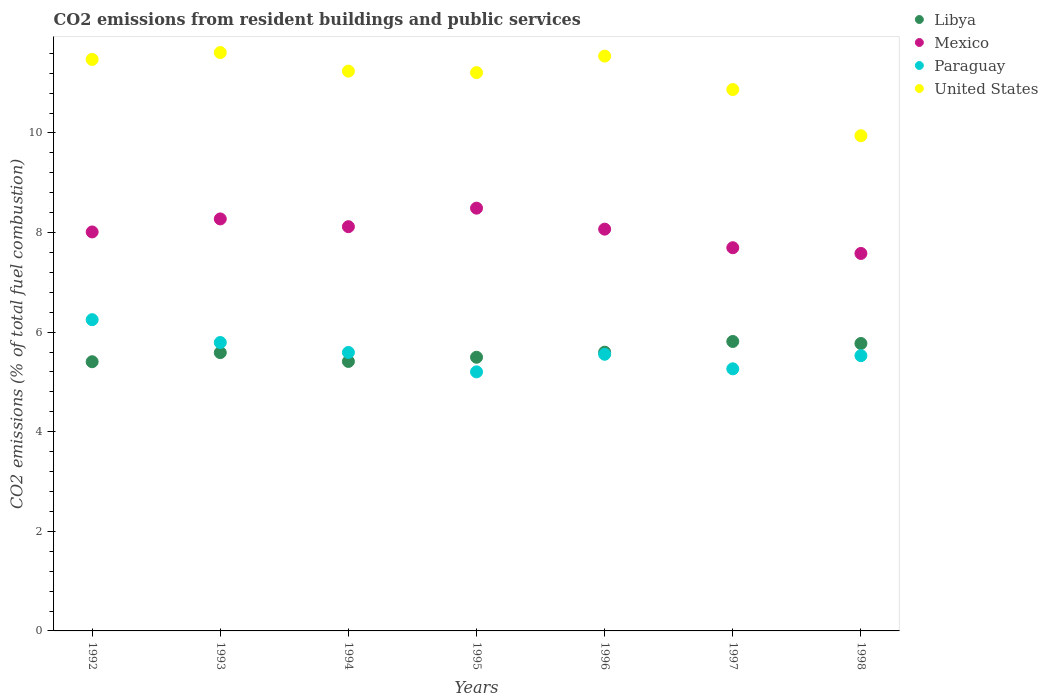How many different coloured dotlines are there?
Ensure brevity in your answer.  4. Is the number of dotlines equal to the number of legend labels?
Ensure brevity in your answer.  Yes. What is the total CO2 emitted in United States in 1997?
Your answer should be very brief. 10.87. Across all years, what is the maximum total CO2 emitted in Libya?
Offer a very short reply. 5.81. Across all years, what is the minimum total CO2 emitted in Libya?
Offer a very short reply. 5.41. In which year was the total CO2 emitted in Paraguay minimum?
Keep it short and to the point. 1995. What is the total total CO2 emitted in Paraguay in the graph?
Keep it short and to the point. 39.18. What is the difference between the total CO2 emitted in Paraguay in 1992 and that in 1998?
Provide a short and direct response. 0.72. What is the difference between the total CO2 emitted in United States in 1994 and the total CO2 emitted in Paraguay in 1997?
Make the answer very short. 5.98. What is the average total CO2 emitted in Libya per year?
Give a very brief answer. 5.58. In the year 1995, what is the difference between the total CO2 emitted in Paraguay and total CO2 emitted in United States?
Your answer should be very brief. -6.01. What is the ratio of the total CO2 emitted in United States in 1992 to that in 1994?
Your answer should be very brief. 1.02. Is the total CO2 emitted in Mexico in 1994 less than that in 1995?
Give a very brief answer. Yes. Is the difference between the total CO2 emitted in Paraguay in 1995 and 1996 greater than the difference between the total CO2 emitted in United States in 1995 and 1996?
Give a very brief answer. No. What is the difference between the highest and the second highest total CO2 emitted in United States?
Offer a terse response. 0.07. What is the difference between the highest and the lowest total CO2 emitted in United States?
Provide a succinct answer. 1.67. Is the sum of the total CO2 emitted in United States in 1994 and 1996 greater than the maximum total CO2 emitted in Libya across all years?
Give a very brief answer. Yes. Is it the case that in every year, the sum of the total CO2 emitted in Libya and total CO2 emitted in Mexico  is greater than the sum of total CO2 emitted in Paraguay and total CO2 emitted in United States?
Your answer should be very brief. No. Does the total CO2 emitted in Mexico monotonically increase over the years?
Give a very brief answer. No. What is the difference between two consecutive major ticks on the Y-axis?
Provide a succinct answer. 2. Are the values on the major ticks of Y-axis written in scientific E-notation?
Provide a short and direct response. No. Does the graph contain any zero values?
Give a very brief answer. No. Does the graph contain grids?
Offer a very short reply. No. Where does the legend appear in the graph?
Your answer should be very brief. Top right. How many legend labels are there?
Your response must be concise. 4. What is the title of the graph?
Provide a short and direct response. CO2 emissions from resident buildings and public services. What is the label or title of the Y-axis?
Offer a very short reply. CO2 emissions (% of total fuel combustion). What is the CO2 emissions (% of total fuel combustion) of Libya in 1992?
Make the answer very short. 5.41. What is the CO2 emissions (% of total fuel combustion) of Mexico in 1992?
Your answer should be very brief. 8.01. What is the CO2 emissions (% of total fuel combustion) in Paraguay in 1992?
Give a very brief answer. 6.25. What is the CO2 emissions (% of total fuel combustion) in United States in 1992?
Provide a short and direct response. 11.48. What is the CO2 emissions (% of total fuel combustion) of Libya in 1993?
Keep it short and to the point. 5.59. What is the CO2 emissions (% of total fuel combustion) of Mexico in 1993?
Offer a very short reply. 8.27. What is the CO2 emissions (% of total fuel combustion) in Paraguay in 1993?
Keep it short and to the point. 5.79. What is the CO2 emissions (% of total fuel combustion) in United States in 1993?
Provide a short and direct response. 11.61. What is the CO2 emissions (% of total fuel combustion) of Libya in 1994?
Keep it short and to the point. 5.41. What is the CO2 emissions (% of total fuel combustion) of Mexico in 1994?
Ensure brevity in your answer.  8.12. What is the CO2 emissions (% of total fuel combustion) in Paraguay in 1994?
Give a very brief answer. 5.59. What is the CO2 emissions (% of total fuel combustion) in United States in 1994?
Keep it short and to the point. 11.24. What is the CO2 emissions (% of total fuel combustion) in Libya in 1995?
Your answer should be compact. 5.5. What is the CO2 emissions (% of total fuel combustion) of Mexico in 1995?
Your response must be concise. 8.49. What is the CO2 emissions (% of total fuel combustion) in Paraguay in 1995?
Ensure brevity in your answer.  5.2. What is the CO2 emissions (% of total fuel combustion) of United States in 1995?
Give a very brief answer. 11.21. What is the CO2 emissions (% of total fuel combustion) of Libya in 1996?
Your answer should be very brief. 5.6. What is the CO2 emissions (% of total fuel combustion) in Mexico in 1996?
Ensure brevity in your answer.  8.07. What is the CO2 emissions (% of total fuel combustion) in Paraguay in 1996?
Your answer should be compact. 5.56. What is the CO2 emissions (% of total fuel combustion) in United States in 1996?
Provide a short and direct response. 11.54. What is the CO2 emissions (% of total fuel combustion) in Libya in 1997?
Your answer should be very brief. 5.81. What is the CO2 emissions (% of total fuel combustion) in Mexico in 1997?
Provide a succinct answer. 7.69. What is the CO2 emissions (% of total fuel combustion) in Paraguay in 1997?
Keep it short and to the point. 5.26. What is the CO2 emissions (% of total fuel combustion) of United States in 1997?
Make the answer very short. 10.87. What is the CO2 emissions (% of total fuel combustion) of Libya in 1998?
Your answer should be very brief. 5.77. What is the CO2 emissions (% of total fuel combustion) in Mexico in 1998?
Your response must be concise. 7.58. What is the CO2 emissions (% of total fuel combustion) in Paraguay in 1998?
Offer a terse response. 5.53. What is the CO2 emissions (% of total fuel combustion) in United States in 1998?
Offer a very short reply. 9.94. Across all years, what is the maximum CO2 emissions (% of total fuel combustion) of Libya?
Your answer should be very brief. 5.81. Across all years, what is the maximum CO2 emissions (% of total fuel combustion) of Mexico?
Offer a terse response. 8.49. Across all years, what is the maximum CO2 emissions (% of total fuel combustion) of Paraguay?
Give a very brief answer. 6.25. Across all years, what is the maximum CO2 emissions (% of total fuel combustion) in United States?
Offer a terse response. 11.61. Across all years, what is the minimum CO2 emissions (% of total fuel combustion) of Libya?
Provide a short and direct response. 5.41. Across all years, what is the minimum CO2 emissions (% of total fuel combustion) in Mexico?
Offer a very short reply. 7.58. Across all years, what is the minimum CO2 emissions (% of total fuel combustion) of Paraguay?
Ensure brevity in your answer.  5.2. Across all years, what is the minimum CO2 emissions (% of total fuel combustion) in United States?
Offer a very short reply. 9.94. What is the total CO2 emissions (% of total fuel combustion) in Libya in the graph?
Provide a short and direct response. 39.08. What is the total CO2 emissions (% of total fuel combustion) of Mexico in the graph?
Offer a very short reply. 56.24. What is the total CO2 emissions (% of total fuel combustion) in Paraguay in the graph?
Your answer should be very brief. 39.18. What is the total CO2 emissions (% of total fuel combustion) of United States in the graph?
Your answer should be very brief. 77.9. What is the difference between the CO2 emissions (% of total fuel combustion) of Libya in 1992 and that in 1993?
Keep it short and to the point. -0.18. What is the difference between the CO2 emissions (% of total fuel combustion) of Mexico in 1992 and that in 1993?
Keep it short and to the point. -0.26. What is the difference between the CO2 emissions (% of total fuel combustion) in Paraguay in 1992 and that in 1993?
Provide a short and direct response. 0.46. What is the difference between the CO2 emissions (% of total fuel combustion) of United States in 1992 and that in 1993?
Offer a terse response. -0.14. What is the difference between the CO2 emissions (% of total fuel combustion) in Libya in 1992 and that in 1994?
Make the answer very short. -0.01. What is the difference between the CO2 emissions (% of total fuel combustion) in Mexico in 1992 and that in 1994?
Give a very brief answer. -0.11. What is the difference between the CO2 emissions (% of total fuel combustion) of Paraguay in 1992 and that in 1994?
Your answer should be very brief. 0.66. What is the difference between the CO2 emissions (% of total fuel combustion) of United States in 1992 and that in 1994?
Provide a succinct answer. 0.23. What is the difference between the CO2 emissions (% of total fuel combustion) of Libya in 1992 and that in 1995?
Your answer should be compact. -0.09. What is the difference between the CO2 emissions (% of total fuel combustion) of Mexico in 1992 and that in 1995?
Offer a terse response. -0.48. What is the difference between the CO2 emissions (% of total fuel combustion) of Paraguay in 1992 and that in 1995?
Your response must be concise. 1.05. What is the difference between the CO2 emissions (% of total fuel combustion) of United States in 1992 and that in 1995?
Your response must be concise. 0.26. What is the difference between the CO2 emissions (% of total fuel combustion) in Libya in 1992 and that in 1996?
Offer a very short reply. -0.19. What is the difference between the CO2 emissions (% of total fuel combustion) in Mexico in 1992 and that in 1996?
Give a very brief answer. -0.06. What is the difference between the CO2 emissions (% of total fuel combustion) of Paraguay in 1992 and that in 1996?
Offer a very short reply. 0.69. What is the difference between the CO2 emissions (% of total fuel combustion) in United States in 1992 and that in 1996?
Ensure brevity in your answer.  -0.07. What is the difference between the CO2 emissions (% of total fuel combustion) in Libya in 1992 and that in 1997?
Your answer should be very brief. -0.41. What is the difference between the CO2 emissions (% of total fuel combustion) in Mexico in 1992 and that in 1997?
Your answer should be very brief. 0.32. What is the difference between the CO2 emissions (% of total fuel combustion) in United States in 1992 and that in 1997?
Provide a succinct answer. 0.6. What is the difference between the CO2 emissions (% of total fuel combustion) in Libya in 1992 and that in 1998?
Offer a very short reply. -0.37. What is the difference between the CO2 emissions (% of total fuel combustion) in Mexico in 1992 and that in 1998?
Provide a short and direct response. 0.43. What is the difference between the CO2 emissions (% of total fuel combustion) of Paraguay in 1992 and that in 1998?
Offer a very short reply. 0.72. What is the difference between the CO2 emissions (% of total fuel combustion) in United States in 1992 and that in 1998?
Your response must be concise. 1.53. What is the difference between the CO2 emissions (% of total fuel combustion) in Libya in 1993 and that in 1994?
Give a very brief answer. 0.18. What is the difference between the CO2 emissions (% of total fuel combustion) in Mexico in 1993 and that in 1994?
Ensure brevity in your answer.  0.16. What is the difference between the CO2 emissions (% of total fuel combustion) in Paraguay in 1993 and that in 1994?
Keep it short and to the point. 0.2. What is the difference between the CO2 emissions (% of total fuel combustion) in United States in 1993 and that in 1994?
Your response must be concise. 0.37. What is the difference between the CO2 emissions (% of total fuel combustion) of Libya in 1993 and that in 1995?
Ensure brevity in your answer.  0.09. What is the difference between the CO2 emissions (% of total fuel combustion) of Mexico in 1993 and that in 1995?
Your response must be concise. -0.22. What is the difference between the CO2 emissions (% of total fuel combustion) in Paraguay in 1993 and that in 1995?
Provide a succinct answer. 0.59. What is the difference between the CO2 emissions (% of total fuel combustion) in United States in 1993 and that in 1995?
Offer a terse response. 0.4. What is the difference between the CO2 emissions (% of total fuel combustion) in Libya in 1993 and that in 1996?
Provide a succinct answer. -0.01. What is the difference between the CO2 emissions (% of total fuel combustion) of Mexico in 1993 and that in 1996?
Provide a succinct answer. 0.21. What is the difference between the CO2 emissions (% of total fuel combustion) in Paraguay in 1993 and that in 1996?
Keep it short and to the point. 0.24. What is the difference between the CO2 emissions (% of total fuel combustion) in United States in 1993 and that in 1996?
Ensure brevity in your answer.  0.07. What is the difference between the CO2 emissions (% of total fuel combustion) of Libya in 1993 and that in 1997?
Keep it short and to the point. -0.22. What is the difference between the CO2 emissions (% of total fuel combustion) in Mexico in 1993 and that in 1997?
Your answer should be very brief. 0.58. What is the difference between the CO2 emissions (% of total fuel combustion) of Paraguay in 1993 and that in 1997?
Keep it short and to the point. 0.53. What is the difference between the CO2 emissions (% of total fuel combustion) of United States in 1993 and that in 1997?
Offer a terse response. 0.74. What is the difference between the CO2 emissions (% of total fuel combustion) in Libya in 1993 and that in 1998?
Provide a succinct answer. -0.18. What is the difference between the CO2 emissions (% of total fuel combustion) in Mexico in 1993 and that in 1998?
Provide a short and direct response. 0.69. What is the difference between the CO2 emissions (% of total fuel combustion) in Paraguay in 1993 and that in 1998?
Your response must be concise. 0.26. What is the difference between the CO2 emissions (% of total fuel combustion) in United States in 1993 and that in 1998?
Provide a succinct answer. 1.67. What is the difference between the CO2 emissions (% of total fuel combustion) in Libya in 1994 and that in 1995?
Ensure brevity in your answer.  -0.08. What is the difference between the CO2 emissions (% of total fuel combustion) in Mexico in 1994 and that in 1995?
Offer a very short reply. -0.37. What is the difference between the CO2 emissions (% of total fuel combustion) of Paraguay in 1994 and that in 1995?
Make the answer very short. 0.39. What is the difference between the CO2 emissions (% of total fuel combustion) in United States in 1994 and that in 1995?
Your response must be concise. 0.03. What is the difference between the CO2 emissions (% of total fuel combustion) in Libya in 1994 and that in 1996?
Your answer should be very brief. -0.19. What is the difference between the CO2 emissions (% of total fuel combustion) of Mexico in 1994 and that in 1996?
Keep it short and to the point. 0.05. What is the difference between the CO2 emissions (% of total fuel combustion) of Paraguay in 1994 and that in 1996?
Make the answer very short. 0.04. What is the difference between the CO2 emissions (% of total fuel combustion) in United States in 1994 and that in 1996?
Provide a succinct answer. -0.3. What is the difference between the CO2 emissions (% of total fuel combustion) in Libya in 1994 and that in 1997?
Offer a very short reply. -0.4. What is the difference between the CO2 emissions (% of total fuel combustion) of Mexico in 1994 and that in 1997?
Give a very brief answer. 0.42. What is the difference between the CO2 emissions (% of total fuel combustion) in Paraguay in 1994 and that in 1997?
Offer a very short reply. 0.33. What is the difference between the CO2 emissions (% of total fuel combustion) in United States in 1994 and that in 1997?
Ensure brevity in your answer.  0.37. What is the difference between the CO2 emissions (% of total fuel combustion) of Libya in 1994 and that in 1998?
Ensure brevity in your answer.  -0.36. What is the difference between the CO2 emissions (% of total fuel combustion) of Mexico in 1994 and that in 1998?
Ensure brevity in your answer.  0.54. What is the difference between the CO2 emissions (% of total fuel combustion) in Paraguay in 1994 and that in 1998?
Provide a short and direct response. 0.06. What is the difference between the CO2 emissions (% of total fuel combustion) in United States in 1994 and that in 1998?
Provide a succinct answer. 1.3. What is the difference between the CO2 emissions (% of total fuel combustion) in Libya in 1995 and that in 1996?
Offer a terse response. -0.1. What is the difference between the CO2 emissions (% of total fuel combustion) in Mexico in 1995 and that in 1996?
Provide a succinct answer. 0.42. What is the difference between the CO2 emissions (% of total fuel combustion) of Paraguay in 1995 and that in 1996?
Make the answer very short. -0.35. What is the difference between the CO2 emissions (% of total fuel combustion) in United States in 1995 and that in 1996?
Your answer should be very brief. -0.33. What is the difference between the CO2 emissions (% of total fuel combustion) of Libya in 1995 and that in 1997?
Give a very brief answer. -0.32. What is the difference between the CO2 emissions (% of total fuel combustion) of Mexico in 1995 and that in 1997?
Give a very brief answer. 0.79. What is the difference between the CO2 emissions (% of total fuel combustion) of Paraguay in 1995 and that in 1997?
Your response must be concise. -0.06. What is the difference between the CO2 emissions (% of total fuel combustion) of United States in 1995 and that in 1997?
Your answer should be very brief. 0.34. What is the difference between the CO2 emissions (% of total fuel combustion) of Libya in 1995 and that in 1998?
Offer a very short reply. -0.28. What is the difference between the CO2 emissions (% of total fuel combustion) in Mexico in 1995 and that in 1998?
Keep it short and to the point. 0.91. What is the difference between the CO2 emissions (% of total fuel combustion) of Paraguay in 1995 and that in 1998?
Provide a short and direct response. -0.33. What is the difference between the CO2 emissions (% of total fuel combustion) of United States in 1995 and that in 1998?
Keep it short and to the point. 1.27. What is the difference between the CO2 emissions (% of total fuel combustion) in Libya in 1996 and that in 1997?
Your response must be concise. -0.21. What is the difference between the CO2 emissions (% of total fuel combustion) in Mexico in 1996 and that in 1997?
Ensure brevity in your answer.  0.37. What is the difference between the CO2 emissions (% of total fuel combustion) of Paraguay in 1996 and that in 1997?
Provide a succinct answer. 0.29. What is the difference between the CO2 emissions (% of total fuel combustion) of United States in 1996 and that in 1997?
Offer a very short reply. 0.67. What is the difference between the CO2 emissions (% of total fuel combustion) in Libya in 1996 and that in 1998?
Keep it short and to the point. -0.17. What is the difference between the CO2 emissions (% of total fuel combustion) of Mexico in 1996 and that in 1998?
Offer a very short reply. 0.49. What is the difference between the CO2 emissions (% of total fuel combustion) in Paraguay in 1996 and that in 1998?
Your answer should be compact. 0.03. What is the difference between the CO2 emissions (% of total fuel combustion) in United States in 1996 and that in 1998?
Make the answer very short. 1.6. What is the difference between the CO2 emissions (% of total fuel combustion) in Libya in 1997 and that in 1998?
Keep it short and to the point. 0.04. What is the difference between the CO2 emissions (% of total fuel combustion) in Mexico in 1997 and that in 1998?
Provide a short and direct response. 0.11. What is the difference between the CO2 emissions (% of total fuel combustion) of Paraguay in 1997 and that in 1998?
Make the answer very short. -0.26. What is the difference between the CO2 emissions (% of total fuel combustion) of United States in 1997 and that in 1998?
Your response must be concise. 0.93. What is the difference between the CO2 emissions (% of total fuel combustion) in Libya in 1992 and the CO2 emissions (% of total fuel combustion) in Mexico in 1993?
Your response must be concise. -2.87. What is the difference between the CO2 emissions (% of total fuel combustion) in Libya in 1992 and the CO2 emissions (% of total fuel combustion) in Paraguay in 1993?
Ensure brevity in your answer.  -0.39. What is the difference between the CO2 emissions (% of total fuel combustion) of Libya in 1992 and the CO2 emissions (% of total fuel combustion) of United States in 1993?
Ensure brevity in your answer.  -6.21. What is the difference between the CO2 emissions (% of total fuel combustion) of Mexico in 1992 and the CO2 emissions (% of total fuel combustion) of Paraguay in 1993?
Your answer should be compact. 2.22. What is the difference between the CO2 emissions (% of total fuel combustion) of Mexico in 1992 and the CO2 emissions (% of total fuel combustion) of United States in 1993?
Your answer should be very brief. -3.6. What is the difference between the CO2 emissions (% of total fuel combustion) of Paraguay in 1992 and the CO2 emissions (% of total fuel combustion) of United States in 1993?
Offer a very short reply. -5.36. What is the difference between the CO2 emissions (% of total fuel combustion) in Libya in 1992 and the CO2 emissions (% of total fuel combustion) in Mexico in 1994?
Your response must be concise. -2.71. What is the difference between the CO2 emissions (% of total fuel combustion) of Libya in 1992 and the CO2 emissions (% of total fuel combustion) of Paraguay in 1994?
Provide a succinct answer. -0.19. What is the difference between the CO2 emissions (% of total fuel combustion) in Libya in 1992 and the CO2 emissions (% of total fuel combustion) in United States in 1994?
Offer a terse response. -5.84. What is the difference between the CO2 emissions (% of total fuel combustion) of Mexico in 1992 and the CO2 emissions (% of total fuel combustion) of Paraguay in 1994?
Your answer should be very brief. 2.42. What is the difference between the CO2 emissions (% of total fuel combustion) in Mexico in 1992 and the CO2 emissions (% of total fuel combustion) in United States in 1994?
Ensure brevity in your answer.  -3.23. What is the difference between the CO2 emissions (% of total fuel combustion) in Paraguay in 1992 and the CO2 emissions (% of total fuel combustion) in United States in 1994?
Give a very brief answer. -4.99. What is the difference between the CO2 emissions (% of total fuel combustion) of Libya in 1992 and the CO2 emissions (% of total fuel combustion) of Mexico in 1995?
Your response must be concise. -3.08. What is the difference between the CO2 emissions (% of total fuel combustion) of Libya in 1992 and the CO2 emissions (% of total fuel combustion) of Paraguay in 1995?
Ensure brevity in your answer.  0.2. What is the difference between the CO2 emissions (% of total fuel combustion) of Libya in 1992 and the CO2 emissions (% of total fuel combustion) of United States in 1995?
Your answer should be very brief. -5.81. What is the difference between the CO2 emissions (% of total fuel combustion) of Mexico in 1992 and the CO2 emissions (% of total fuel combustion) of Paraguay in 1995?
Ensure brevity in your answer.  2.81. What is the difference between the CO2 emissions (% of total fuel combustion) of Mexico in 1992 and the CO2 emissions (% of total fuel combustion) of United States in 1995?
Keep it short and to the point. -3.2. What is the difference between the CO2 emissions (% of total fuel combustion) in Paraguay in 1992 and the CO2 emissions (% of total fuel combustion) in United States in 1995?
Your response must be concise. -4.96. What is the difference between the CO2 emissions (% of total fuel combustion) of Libya in 1992 and the CO2 emissions (% of total fuel combustion) of Mexico in 1996?
Provide a succinct answer. -2.66. What is the difference between the CO2 emissions (% of total fuel combustion) of Libya in 1992 and the CO2 emissions (% of total fuel combustion) of Paraguay in 1996?
Provide a short and direct response. -0.15. What is the difference between the CO2 emissions (% of total fuel combustion) in Libya in 1992 and the CO2 emissions (% of total fuel combustion) in United States in 1996?
Give a very brief answer. -6.14. What is the difference between the CO2 emissions (% of total fuel combustion) in Mexico in 1992 and the CO2 emissions (% of total fuel combustion) in Paraguay in 1996?
Your answer should be compact. 2.46. What is the difference between the CO2 emissions (% of total fuel combustion) in Mexico in 1992 and the CO2 emissions (% of total fuel combustion) in United States in 1996?
Give a very brief answer. -3.53. What is the difference between the CO2 emissions (% of total fuel combustion) in Paraguay in 1992 and the CO2 emissions (% of total fuel combustion) in United States in 1996?
Keep it short and to the point. -5.29. What is the difference between the CO2 emissions (% of total fuel combustion) of Libya in 1992 and the CO2 emissions (% of total fuel combustion) of Mexico in 1997?
Make the answer very short. -2.29. What is the difference between the CO2 emissions (% of total fuel combustion) in Libya in 1992 and the CO2 emissions (% of total fuel combustion) in Paraguay in 1997?
Your response must be concise. 0.14. What is the difference between the CO2 emissions (% of total fuel combustion) in Libya in 1992 and the CO2 emissions (% of total fuel combustion) in United States in 1997?
Offer a very short reply. -5.47. What is the difference between the CO2 emissions (% of total fuel combustion) in Mexico in 1992 and the CO2 emissions (% of total fuel combustion) in Paraguay in 1997?
Your answer should be compact. 2.75. What is the difference between the CO2 emissions (% of total fuel combustion) in Mexico in 1992 and the CO2 emissions (% of total fuel combustion) in United States in 1997?
Make the answer very short. -2.86. What is the difference between the CO2 emissions (% of total fuel combustion) in Paraguay in 1992 and the CO2 emissions (% of total fuel combustion) in United States in 1997?
Provide a short and direct response. -4.62. What is the difference between the CO2 emissions (% of total fuel combustion) of Libya in 1992 and the CO2 emissions (% of total fuel combustion) of Mexico in 1998?
Your answer should be very brief. -2.17. What is the difference between the CO2 emissions (% of total fuel combustion) of Libya in 1992 and the CO2 emissions (% of total fuel combustion) of Paraguay in 1998?
Provide a succinct answer. -0.12. What is the difference between the CO2 emissions (% of total fuel combustion) of Libya in 1992 and the CO2 emissions (% of total fuel combustion) of United States in 1998?
Offer a very short reply. -4.54. What is the difference between the CO2 emissions (% of total fuel combustion) in Mexico in 1992 and the CO2 emissions (% of total fuel combustion) in Paraguay in 1998?
Your answer should be very brief. 2.48. What is the difference between the CO2 emissions (% of total fuel combustion) of Mexico in 1992 and the CO2 emissions (% of total fuel combustion) of United States in 1998?
Your answer should be very brief. -1.93. What is the difference between the CO2 emissions (% of total fuel combustion) in Paraguay in 1992 and the CO2 emissions (% of total fuel combustion) in United States in 1998?
Your response must be concise. -3.69. What is the difference between the CO2 emissions (% of total fuel combustion) of Libya in 1993 and the CO2 emissions (% of total fuel combustion) of Mexico in 1994?
Provide a succinct answer. -2.53. What is the difference between the CO2 emissions (% of total fuel combustion) of Libya in 1993 and the CO2 emissions (% of total fuel combustion) of Paraguay in 1994?
Give a very brief answer. -0. What is the difference between the CO2 emissions (% of total fuel combustion) of Libya in 1993 and the CO2 emissions (% of total fuel combustion) of United States in 1994?
Offer a terse response. -5.65. What is the difference between the CO2 emissions (% of total fuel combustion) of Mexico in 1993 and the CO2 emissions (% of total fuel combustion) of Paraguay in 1994?
Your answer should be compact. 2.68. What is the difference between the CO2 emissions (% of total fuel combustion) in Mexico in 1993 and the CO2 emissions (% of total fuel combustion) in United States in 1994?
Make the answer very short. -2.97. What is the difference between the CO2 emissions (% of total fuel combustion) in Paraguay in 1993 and the CO2 emissions (% of total fuel combustion) in United States in 1994?
Provide a succinct answer. -5.45. What is the difference between the CO2 emissions (% of total fuel combustion) in Libya in 1993 and the CO2 emissions (% of total fuel combustion) in Mexico in 1995?
Your answer should be very brief. -2.9. What is the difference between the CO2 emissions (% of total fuel combustion) in Libya in 1993 and the CO2 emissions (% of total fuel combustion) in Paraguay in 1995?
Your answer should be very brief. 0.39. What is the difference between the CO2 emissions (% of total fuel combustion) in Libya in 1993 and the CO2 emissions (% of total fuel combustion) in United States in 1995?
Make the answer very short. -5.62. What is the difference between the CO2 emissions (% of total fuel combustion) of Mexico in 1993 and the CO2 emissions (% of total fuel combustion) of Paraguay in 1995?
Your answer should be very brief. 3.07. What is the difference between the CO2 emissions (% of total fuel combustion) in Mexico in 1993 and the CO2 emissions (% of total fuel combustion) in United States in 1995?
Keep it short and to the point. -2.94. What is the difference between the CO2 emissions (% of total fuel combustion) of Paraguay in 1993 and the CO2 emissions (% of total fuel combustion) of United States in 1995?
Provide a succinct answer. -5.42. What is the difference between the CO2 emissions (% of total fuel combustion) in Libya in 1993 and the CO2 emissions (% of total fuel combustion) in Mexico in 1996?
Your response must be concise. -2.48. What is the difference between the CO2 emissions (% of total fuel combustion) in Libya in 1993 and the CO2 emissions (% of total fuel combustion) in Paraguay in 1996?
Ensure brevity in your answer.  0.03. What is the difference between the CO2 emissions (% of total fuel combustion) of Libya in 1993 and the CO2 emissions (% of total fuel combustion) of United States in 1996?
Your answer should be compact. -5.95. What is the difference between the CO2 emissions (% of total fuel combustion) in Mexico in 1993 and the CO2 emissions (% of total fuel combustion) in Paraguay in 1996?
Make the answer very short. 2.72. What is the difference between the CO2 emissions (% of total fuel combustion) of Mexico in 1993 and the CO2 emissions (% of total fuel combustion) of United States in 1996?
Offer a terse response. -3.27. What is the difference between the CO2 emissions (% of total fuel combustion) of Paraguay in 1993 and the CO2 emissions (% of total fuel combustion) of United States in 1996?
Your answer should be compact. -5.75. What is the difference between the CO2 emissions (% of total fuel combustion) in Libya in 1993 and the CO2 emissions (% of total fuel combustion) in Mexico in 1997?
Ensure brevity in your answer.  -2.11. What is the difference between the CO2 emissions (% of total fuel combustion) of Libya in 1993 and the CO2 emissions (% of total fuel combustion) of Paraguay in 1997?
Ensure brevity in your answer.  0.33. What is the difference between the CO2 emissions (% of total fuel combustion) of Libya in 1993 and the CO2 emissions (% of total fuel combustion) of United States in 1997?
Make the answer very short. -5.28. What is the difference between the CO2 emissions (% of total fuel combustion) of Mexico in 1993 and the CO2 emissions (% of total fuel combustion) of Paraguay in 1997?
Provide a short and direct response. 3.01. What is the difference between the CO2 emissions (% of total fuel combustion) of Mexico in 1993 and the CO2 emissions (% of total fuel combustion) of United States in 1997?
Provide a succinct answer. -2.6. What is the difference between the CO2 emissions (% of total fuel combustion) of Paraguay in 1993 and the CO2 emissions (% of total fuel combustion) of United States in 1997?
Your answer should be compact. -5.08. What is the difference between the CO2 emissions (% of total fuel combustion) of Libya in 1993 and the CO2 emissions (% of total fuel combustion) of Mexico in 1998?
Offer a terse response. -1.99. What is the difference between the CO2 emissions (% of total fuel combustion) of Libya in 1993 and the CO2 emissions (% of total fuel combustion) of Paraguay in 1998?
Your response must be concise. 0.06. What is the difference between the CO2 emissions (% of total fuel combustion) in Libya in 1993 and the CO2 emissions (% of total fuel combustion) in United States in 1998?
Offer a very short reply. -4.36. What is the difference between the CO2 emissions (% of total fuel combustion) of Mexico in 1993 and the CO2 emissions (% of total fuel combustion) of Paraguay in 1998?
Provide a succinct answer. 2.75. What is the difference between the CO2 emissions (% of total fuel combustion) in Mexico in 1993 and the CO2 emissions (% of total fuel combustion) in United States in 1998?
Keep it short and to the point. -1.67. What is the difference between the CO2 emissions (% of total fuel combustion) of Paraguay in 1993 and the CO2 emissions (% of total fuel combustion) of United States in 1998?
Your response must be concise. -4.15. What is the difference between the CO2 emissions (% of total fuel combustion) of Libya in 1994 and the CO2 emissions (% of total fuel combustion) of Mexico in 1995?
Ensure brevity in your answer.  -3.08. What is the difference between the CO2 emissions (% of total fuel combustion) of Libya in 1994 and the CO2 emissions (% of total fuel combustion) of Paraguay in 1995?
Your answer should be compact. 0.21. What is the difference between the CO2 emissions (% of total fuel combustion) of Libya in 1994 and the CO2 emissions (% of total fuel combustion) of United States in 1995?
Give a very brief answer. -5.8. What is the difference between the CO2 emissions (% of total fuel combustion) of Mexico in 1994 and the CO2 emissions (% of total fuel combustion) of Paraguay in 1995?
Your answer should be very brief. 2.92. What is the difference between the CO2 emissions (% of total fuel combustion) in Mexico in 1994 and the CO2 emissions (% of total fuel combustion) in United States in 1995?
Keep it short and to the point. -3.09. What is the difference between the CO2 emissions (% of total fuel combustion) in Paraguay in 1994 and the CO2 emissions (% of total fuel combustion) in United States in 1995?
Offer a very short reply. -5.62. What is the difference between the CO2 emissions (% of total fuel combustion) in Libya in 1994 and the CO2 emissions (% of total fuel combustion) in Mexico in 1996?
Give a very brief answer. -2.66. What is the difference between the CO2 emissions (% of total fuel combustion) of Libya in 1994 and the CO2 emissions (% of total fuel combustion) of Paraguay in 1996?
Provide a short and direct response. -0.14. What is the difference between the CO2 emissions (% of total fuel combustion) of Libya in 1994 and the CO2 emissions (% of total fuel combustion) of United States in 1996?
Your answer should be compact. -6.13. What is the difference between the CO2 emissions (% of total fuel combustion) of Mexico in 1994 and the CO2 emissions (% of total fuel combustion) of Paraguay in 1996?
Ensure brevity in your answer.  2.56. What is the difference between the CO2 emissions (% of total fuel combustion) in Mexico in 1994 and the CO2 emissions (% of total fuel combustion) in United States in 1996?
Your response must be concise. -3.43. What is the difference between the CO2 emissions (% of total fuel combustion) in Paraguay in 1994 and the CO2 emissions (% of total fuel combustion) in United States in 1996?
Offer a terse response. -5.95. What is the difference between the CO2 emissions (% of total fuel combustion) in Libya in 1994 and the CO2 emissions (% of total fuel combustion) in Mexico in 1997?
Make the answer very short. -2.28. What is the difference between the CO2 emissions (% of total fuel combustion) in Libya in 1994 and the CO2 emissions (% of total fuel combustion) in Paraguay in 1997?
Offer a very short reply. 0.15. What is the difference between the CO2 emissions (% of total fuel combustion) of Libya in 1994 and the CO2 emissions (% of total fuel combustion) of United States in 1997?
Offer a very short reply. -5.46. What is the difference between the CO2 emissions (% of total fuel combustion) in Mexico in 1994 and the CO2 emissions (% of total fuel combustion) in Paraguay in 1997?
Offer a terse response. 2.85. What is the difference between the CO2 emissions (% of total fuel combustion) in Mexico in 1994 and the CO2 emissions (% of total fuel combustion) in United States in 1997?
Give a very brief answer. -2.75. What is the difference between the CO2 emissions (% of total fuel combustion) of Paraguay in 1994 and the CO2 emissions (% of total fuel combustion) of United States in 1997?
Your answer should be very brief. -5.28. What is the difference between the CO2 emissions (% of total fuel combustion) of Libya in 1994 and the CO2 emissions (% of total fuel combustion) of Mexico in 1998?
Keep it short and to the point. -2.17. What is the difference between the CO2 emissions (% of total fuel combustion) of Libya in 1994 and the CO2 emissions (% of total fuel combustion) of Paraguay in 1998?
Keep it short and to the point. -0.12. What is the difference between the CO2 emissions (% of total fuel combustion) of Libya in 1994 and the CO2 emissions (% of total fuel combustion) of United States in 1998?
Make the answer very short. -4.53. What is the difference between the CO2 emissions (% of total fuel combustion) of Mexico in 1994 and the CO2 emissions (% of total fuel combustion) of Paraguay in 1998?
Keep it short and to the point. 2.59. What is the difference between the CO2 emissions (% of total fuel combustion) of Mexico in 1994 and the CO2 emissions (% of total fuel combustion) of United States in 1998?
Give a very brief answer. -1.83. What is the difference between the CO2 emissions (% of total fuel combustion) of Paraguay in 1994 and the CO2 emissions (% of total fuel combustion) of United States in 1998?
Offer a very short reply. -4.35. What is the difference between the CO2 emissions (% of total fuel combustion) in Libya in 1995 and the CO2 emissions (% of total fuel combustion) in Mexico in 1996?
Ensure brevity in your answer.  -2.57. What is the difference between the CO2 emissions (% of total fuel combustion) of Libya in 1995 and the CO2 emissions (% of total fuel combustion) of Paraguay in 1996?
Keep it short and to the point. -0.06. What is the difference between the CO2 emissions (% of total fuel combustion) of Libya in 1995 and the CO2 emissions (% of total fuel combustion) of United States in 1996?
Your response must be concise. -6.05. What is the difference between the CO2 emissions (% of total fuel combustion) in Mexico in 1995 and the CO2 emissions (% of total fuel combustion) in Paraguay in 1996?
Your answer should be compact. 2.93. What is the difference between the CO2 emissions (% of total fuel combustion) in Mexico in 1995 and the CO2 emissions (% of total fuel combustion) in United States in 1996?
Give a very brief answer. -3.05. What is the difference between the CO2 emissions (% of total fuel combustion) in Paraguay in 1995 and the CO2 emissions (% of total fuel combustion) in United States in 1996?
Offer a very short reply. -6.34. What is the difference between the CO2 emissions (% of total fuel combustion) in Libya in 1995 and the CO2 emissions (% of total fuel combustion) in Mexico in 1997?
Make the answer very short. -2.2. What is the difference between the CO2 emissions (% of total fuel combustion) in Libya in 1995 and the CO2 emissions (% of total fuel combustion) in Paraguay in 1997?
Provide a short and direct response. 0.23. What is the difference between the CO2 emissions (% of total fuel combustion) of Libya in 1995 and the CO2 emissions (% of total fuel combustion) of United States in 1997?
Ensure brevity in your answer.  -5.38. What is the difference between the CO2 emissions (% of total fuel combustion) in Mexico in 1995 and the CO2 emissions (% of total fuel combustion) in Paraguay in 1997?
Ensure brevity in your answer.  3.23. What is the difference between the CO2 emissions (% of total fuel combustion) in Mexico in 1995 and the CO2 emissions (% of total fuel combustion) in United States in 1997?
Your answer should be compact. -2.38. What is the difference between the CO2 emissions (% of total fuel combustion) of Paraguay in 1995 and the CO2 emissions (% of total fuel combustion) of United States in 1997?
Your answer should be very brief. -5.67. What is the difference between the CO2 emissions (% of total fuel combustion) in Libya in 1995 and the CO2 emissions (% of total fuel combustion) in Mexico in 1998?
Provide a succinct answer. -2.08. What is the difference between the CO2 emissions (% of total fuel combustion) of Libya in 1995 and the CO2 emissions (% of total fuel combustion) of Paraguay in 1998?
Give a very brief answer. -0.03. What is the difference between the CO2 emissions (% of total fuel combustion) in Libya in 1995 and the CO2 emissions (% of total fuel combustion) in United States in 1998?
Ensure brevity in your answer.  -4.45. What is the difference between the CO2 emissions (% of total fuel combustion) in Mexico in 1995 and the CO2 emissions (% of total fuel combustion) in Paraguay in 1998?
Make the answer very short. 2.96. What is the difference between the CO2 emissions (% of total fuel combustion) of Mexico in 1995 and the CO2 emissions (% of total fuel combustion) of United States in 1998?
Your response must be concise. -1.45. What is the difference between the CO2 emissions (% of total fuel combustion) in Paraguay in 1995 and the CO2 emissions (% of total fuel combustion) in United States in 1998?
Your answer should be very brief. -4.74. What is the difference between the CO2 emissions (% of total fuel combustion) in Libya in 1996 and the CO2 emissions (% of total fuel combustion) in Mexico in 1997?
Your answer should be very brief. -2.1. What is the difference between the CO2 emissions (% of total fuel combustion) in Libya in 1996 and the CO2 emissions (% of total fuel combustion) in Paraguay in 1997?
Ensure brevity in your answer.  0.33. What is the difference between the CO2 emissions (% of total fuel combustion) of Libya in 1996 and the CO2 emissions (% of total fuel combustion) of United States in 1997?
Your answer should be compact. -5.27. What is the difference between the CO2 emissions (% of total fuel combustion) of Mexico in 1996 and the CO2 emissions (% of total fuel combustion) of Paraguay in 1997?
Keep it short and to the point. 2.8. What is the difference between the CO2 emissions (% of total fuel combustion) in Mexico in 1996 and the CO2 emissions (% of total fuel combustion) in United States in 1997?
Make the answer very short. -2.8. What is the difference between the CO2 emissions (% of total fuel combustion) of Paraguay in 1996 and the CO2 emissions (% of total fuel combustion) of United States in 1997?
Offer a terse response. -5.32. What is the difference between the CO2 emissions (% of total fuel combustion) of Libya in 1996 and the CO2 emissions (% of total fuel combustion) of Mexico in 1998?
Ensure brevity in your answer.  -1.98. What is the difference between the CO2 emissions (% of total fuel combustion) of Libya in 1996 and the CO2 emissions (% of total fuel combustion) of Paraguay in 1998?
Make the answer very short. 0.07. What is the difference between the CO2 emissions (% of total fuel combustion) of Libya in 1996 and the CO2 emissions (% of total fuel combustion) of United States in 1998?
Provide a succinct answer. -4.35. What is the difference between the CO2 emissions (% of total fuel combustion) in Mexico in 1996 and the CO2 emissions (% of total fuel combustion) in Paraguay in 1998?
Your answer should be very brief. 2.54. What is the difference between the CO2 emissions (% of total fuel combustion) of Mexico in 1996 and the CO2 emissions (% of total fuel combustion) of United States in 1998?
Your response must be concise. -1.88. What is the difference between the CO2 emissions (% of total fuel combustion) in Paraguay in 1996 and the CO2 emissions (% of total fuel combustion) in United States in 1998?
Your answer should be very brief. -4.39. What is the difference between the CO2 emissions (% of total fuel combustion) in Libya in 1997 and the CO2 emissions (% of total fuel combustion) in Mexico in 1998?
Ensure brevity in your answer.  -1.77. What is the difference between the CO2 emissions (% of total fuel combustion) of Libya in 1997 and the CO2 emissions (% of total fuel combustion) of Paraguay in 1998?
Ensure brevity in your answer.  0.28. What is the difference between the CO2 emissions (% of total fuel combustion) of Libya in 1997 and the CO2 emissions (% of total fuel combustion) of United States in 1998?
Ensure brevity in your answer.  -4.13. What is the difference between the CO2 emissions (% of total fuel combustion) of Mexico in 1997 and the CO2 emissions (% of total fuel combustion) of Paraguay in 1998?
Ensure brevity in your answer.  2.17. What is the difference between the CO2 emissions (% of total fuel combustion) in Mexico in 1997 and the CO2 emissions (% of total fuel combustion) in United States in 1998?
Ensure brevity in your answer.  -2.25. What is the difference between the CO2 emissions (% of total fuel combustion) in Paraguay in 1997 and the CO2 emissions (% of total fuel combustion) in United States in 1998?
Give a very brief answer. -4.68. What is the average CO2 emissions (% of total fuel combustion) of Libya per year?
Give a very brief answer. 5.58. What is the average CO2 emissions (% of total fuel combustion) in Mexico per year?
Ensure brevity in your answer.  8.03. What is the average CO2 emissions (% of total fuel combustion) in Paraguay per year?
Your response must be concise. 5.6. What is the average CO2 emissions (% of total fuel combustion) of United States per year?
Offer a very short reply. 11.13. In the year 1992, what is the difference between the CO2 emissions (% of total fuel combustion) in Libya and CO2 emissions (% of total fuel combustion) in Mexico?
Keep it short and to the point. -2.61. In the year 1992, what is the difference between the CO2 emissions (% of total fuel combustion) in Libya and CO2 emissions (% of total fuel combustion) in Paraguay?
Keep it short and to the point. -0.84. In the year 1992, what is the difference between the CO2 emissions (% of total fuel combustion) of Libya and CO2 emissions (% of total fuel combustion) of United States?
Your answer should be very brief. -6.07. In the year 1992, what is the difference between the CO2 emissions (% of total fuel combustion) of Mexico and CO2 emissions (% of total fuel combustion) of Paraguay?
Provide a short and direct response. 1.76. In the year 1992, what is the difference between the CO2 emissions (% of total fuel combustion) of Mexico and CO2 emissions (% of total fuel combustion) of United States?
Give a very brief answer. -3.46. In the year 1992, what is the difference between the CO2 emissions (% of total fuel combustion) in Paraguay and CO2 emissions (% of total fuel combustion) in United States?
Ensure brevity in your answer.  -5.23. In the year 1993, what is the difference between the CO2 emissions (% of total fuel combustion) in Libya and CO2 emissions (% of total fuel combustion) in Mexico?
Keep it short and to the point. -2.68. In the year 1993, what is the difference between the CO2 emissions (% of total fuel combustion) in Libya and CO2 emissions (% of total fuel combustion) in Paraguay?
Make the answer very short. -0.2. In the year 1993, what is the difference between the CO2 emissions (% of total fuel combustion) in Libya and CO2 emissions (% of total fuel combustion) in United States?
Your response must be concise. -6.03. In the year 1993, what is the difference between the CO2 emissions (% of total fuel combustion) in Mexico and CO2 emissions (% of total fuel combustion) in Paraguay?
Offer a very short reply. 2.48. In the year 1993, what is the difference between the CO2 emissions (% of total fuel combustion) in Mexico and CO2 emissions (% of total fuel combustion) in United States?
Ensure brevity in your answer.  -3.34. In the year 1993, what is the difference between the CO2 emissions (% of total fuel combustion) in Paraguay and CO2 emissions (% of total fuel combustion) in United States?
Offer a very short reply. -5.82. In the year 1994, what is the difference between the CO2 emissions (% of total fuel combustion) of Libya and CO2 emissions (% of total fuel combustion) of Mexico?
Ensure brevity in your answer.  -2.71. In the year 1994, what is the difference between the CO2 emissions (% of total fuel combustion) of Libya and CO2 emissions (% of total fuel combustion) of Paraguay?
Give a very brief answer. -0.18. In the year 1994, what is the difference between the CO2 emissions (% of total fuel combustion) of Libya and CO2 emissions (% of total fuel combustion) of United States?
Offer a very short reply. -5.83. In the year 1994, what is the difference between the CO2 emissions (% of total fuel combustion) in Mexico and CO2 emissions (% of total fuel combustion) in Paraguay?
Offer a terse response. 2.53. In the year 1994, what is the difference between the CO2 emissions (% of total fuel combustion) in Mexico and CO2 emissions (% of total fuel combustion) in United States?
Provide a succinct answer. -3.12. In the year 1994, what is the difference between the CO2 emissions (% of total fuel combustion) of Paraguay and CO2 emissions (% of total fuel combustion) of United States?
Your answer should be compact. -5.65. In the year 1995, what is the difference between the CO2 emissions (% of total fuel combustion) in Libya and CO2 emissions (% of total fuel combustion) in Mexico?
Offer a very short reply. -2.99. In the year 1995, what is the difference between the CO2 emissions (% of total fuel combustion) in Libya and CO2 emissions (% of total fuel combustion) in Paraguay?
Give a very brief answer. 0.29. In the year 1995, what is the difference between the CO2 emissions (% of total fuel combustion) in Libya and CO2 emissions (% of total fuel combustion) in United States?
Provide a short and direct response. -5.72. In the year 1995, what is the difference between the CO2 emissions (% of total fuel combustion) of Mexico and CO2 emissions (% of total fuel combustion) of Paraguay?
Offer a terse response. 3.29. In the year 1995, what is the difference between the CO2 emissions (% of total fuel combustion) in Mexico and CO2 emissions (% of total fuel combustion) in United States?
Your answer should be very brief. -2.72. In the year 1995, what is the difference between the CO2 emissions (% of total fuel combustion) in Paraguay and CO2 emissions (% of total fuel combustion) in United States?
Give a very brief answer. -6.01. In the year 1996, what is the difference between the CO2 emissions (% of total fuel combustion) in Libya and CO2 emissions (% of total fuel combustion) in Mexico?
Provide a short and direct response. -2.47. In the year 1996, what is the difference between the CO2 emissions (% of total fuel combustion) of Libya and CO2 emissions (% of total fuel combustion) of Paraguay?
Offer a terse response. 0.04. In the year 1996, what is the difference between the CO2 emissions (% of total fuel combustion) of Libya and CO2 emissions (% of total fuel combustion) of United States?
Keep it short and to the point. -5.95. In the year 1996, what is the difference between the CO2 emissions (% of total fuel combustion) of Mexico and CO2 emissions (% of total fuel combustion) of Paraguay?
Ensure brevity in your answer.  2.51. In the year 1996, what is the difference between the CO2 emissions (% of total fuel combustion) of Mexico and CO2 emissions (% of total fuel combustion) of United States?
Your answer should be very brief. -3.47. In the year 1996, what is the difference between the CO2 emissions (% of total fuel combustion) of Paraguay and CO2 emissions (% of total fuel combustion) of United States?
Your answer should be very brief. -5.99. In the year 1997, what is the difference between the CO2 emissions (% of total fuel combustion) of Libya and CO2 emissions (% of total fuel combustion) of Mexico?
Ensure brevity in your answer.  -1.88. In the year 1997, what is the difference between the CO2 emissions (% of total fuel combustion) of Libya and CO2 emissions (% of total fuel combustion) of Paraguay?
Ensure brevity in your answer.  0.55. In the year 1997, what is the difference between the CO2 emissions (% of total fuel combustion) in Libya and CO2 emissions (% of total fuel combustion) in United States?
Your answer should be very brief. -5.06. In the year 1997, what is the difference between the CO2 emissions (% of total fuel combustion) in Mexico and CO2 emissions (% of total fuel combustion) in Paraguay?
Your answer should be very brief. 2.43. In the year 1997, what is the difference between the CO2 emissions (% of total fuel combustion) in Mexico and CO2 emissions (% of total fuel combustion) in United States?
Provide a succinct answer. -3.18. In the year 1997, what is the difference between the CO2 emissions (% of total fuel combustion) of Paraguay and CO2 emissions (% of total fuel combustion) of United States?
Your answer should be very brief. -5.61. In the year 1998, what is the difference between the CO2 emissions (% of total fuel combustion) of Libya and CO2 emissions (% of total fuel combustion) of Mexico?
Offer a terse response. -1.81. In the year 1998, what is the difference between the CO2 emissions (% of total fuel combustion) in Libya and CO2 emissions (% of total fuel combustion) in Paraguay?
Your answer should be very brief. 0.24. In the year 1998, what is the difference between the CO2 emissions (% of total fuel combustion) of Libya and CO2 emissions (% of total fuel combustion) of United States?
Make the answer very short. -4.17. In the year 1998, what is the difference between the CO2 emissions (% of total fuel combustion) of Mexico and CO2 emissions (% of total fuel combustion) of Paraguay?
Offer a very short reply. 2.05. In the year 1998, what is the difference between the CO2 emissions (% of total fuel combustion) of Mexico and CO2 emissions (% of total fuel combustion) of United States?
Provide a succinct answer. -2.36. In the year 1998, what is the difference between the CO2 emissions (% of total fuel combustion) in Paraguay and CO2 emissions (% of total fuel combustion) in United States?
Provide a short and direct response. -4.42. What is the ratio of the CO2 emissions (% of total fuel combustion) in Libya in 1992 to that in 1993?
Offer a very short reply. 0.97. What is the ratio of the CO2 emissions (% of total fuel combustion) of Mexico in 1992 to that in 1993?
Provide a succinct answer. 0.97. What is the ratio of the CO2 emissions (% of total fuel combustion) of Paraguay in 1992 to that in 1993?
Make the answer very short. 1.08. What is the ratio of the CO2 emissions (% of total fuel combustion) of Paraguay in 1992 to that in 1994?
Provide a succinct answer. 1.12. What is the ratio of the CO2 emissions (% of total fuel combustion) of United States in 1992 to that in 1994?
Your response must be concise. 1.02. What is the ratio of the CO2 emissions (% of total fuel combustion) of Libya in 1992 to that in 1995?
Provide a succinct answer. 0.98. What is the ratio of the CO2 emissions (% of total fuel combustion) of Mexico in 1992 to that in 1995?
Keep it short and to the point. 0.94. What is the ratio of the CO2 emissions (% of total fuel combustion) of Paraguay in 1992 to that in 1995?
Provide a succinct answer. 1.2. What is the ratio of the CO2 emissions (% of total fuel combustion) in United States in 1992 to that in 1995?
Make the answer very short. 1.02. What is the ratio of the CO2 emissions (% of total fuel combustion) of Libya in 1992 to that in 1996?
Provide a short and direct response. 0.97. What is the ratio of the CO2 emissions (% of total fuel combustion) in Mexico in 1992 to that in 1996?
Offer a terse response. 0.99. What is the ratio of the CO2 emissions (% of total fuel combustion) of United States in 1992 to that in 1996?
Make the answer very short. 0.99. What is the ratio of the CO2 emissions (% of total fuel combustion) in Libya in 1992 to that in 1997?
Give a very brief answer. 0.93. What is the ratio of the CO2 emissions (% of total fuel combustion) of Mexico in 1992 to that in 1997?
Your response must be concise. 1.04. What is the ratio of the CO2 emissions (% of total fuel combustion) of Paraguay in 1992 to that in 1997?
Give a very brief answer. 1.19. What is the ratio of the CO2 emissions (% of total fuel combustion) of United States in 1992 to that in 1997?
Offer a terse response. 1.06. What is the ratio of the CO2 emissions (% of total fuel combustion) in Libya in 1992 to that in 1998?
Keep it short and to the point. 0.94. What is the ratio of the CO2 emissions (% of total fuel combustion) of Mexico in 1992 to that in 1998?
Offer a very short reply. 1.06. What is the ratio of the CO2 emissions (% of total fuel combustion) of Paraguay in 1992 to that in 1998?
Provide a short and direct response. 1.13. What is the ratio of the CO2 emissions (% of total fuel combustion) of United States in 1992 to that in 1998?
Keep it short and to the point. 1.15. What is the ratio of the CO2 emissions (% of total fuel combustion) of Libya in 1993 to that in 1994?
Keep it short and to the point. 1.03. What is the ratio of the CO2 emissions (% of total fuel combustion) of Mexico in 1993 to that in 1994?
Offer a very short reply. 1.02. What is the ratio of the CO2 emissions (% of total fuel combustion) in Paraguay in 1993 to that in 1994?
Provide a succinct answer. 1.04. What is the ratio of the CO2 emissions (% of total fuel combustion) in United States in 1993 to that in 1994?
Your answer should be very brief. 1.03. What is the ratio of the CO2 emissions (% of total fuel combustion) of Libya in 1993 to that in 1995?
Give a very brief answer. 1.02. What is the ratio of the CO2 emissions (% of total fuel combustion) in Mexico in 1993 to that in 1995?
Offer a terse response. 0.97. What is the ratio of the CO2 emissions (% of total fuel combustion) of Paraguay in 1993 to that in 1995?
Give a very brief answer. 1.11. What is the ratio of the CO2 emissions (% of total fuel combustion) of United States in 1993 to that in 1995?
Make the answer very short. 1.04. What is the ratio of the CO2 emissions (% of total fuel combustion) of Mexico in 1993 to that in 1996?
Keep it short and to the point. 1.03. What is the ratio of the CO2 emissions (% of total fuel combustion) of Paraguay in 1993 to that in 1996?
Keep it short and to the point. 1.04. What is the ratio of the CO2 emissions (% of total fuel combustion) in United States in 1993 to that in 1996?
Provide a short and direct response. 1.01. What is the ratio of the CO2 emissions (% of total fuel combustion) of Libya in 1993 to that in 1997?
Offer a very short reply. 0.96. What is the ratio of the CO2 emissions (% of total fuel combustion) in Mexico in 1993 to that in 1997?
Your answer should be very brief. 1.08. What is the ratio of the CO2 emissions (% of total fuel combustion) of Paraguay in 1993 to that in 1997?
Make the answer very short. 1.1. What is the ratio of the CO2 emissions (% of total fuel combustion) in United States in 1993 to that in 1997?
Make the answer very short. 1.07. What is the ratio of the CO2 emissions (% of total fuel combustion) in Libya in 1993 to that in 1998?
Offer a very short reply. 0.97. What is the ratio of the CO2 emissions (% of total fuel combustion) in Mexico in 1993 to that in 1998?
Keep it short and to the point. 1.09. What is the ratio of the CO2 emissions (% of total fuel combustion) of Paraguay in 1993 to that in 1998?
Offer a very short reply. 1.05. What is the ratio of the CO2 emissions (% of total fuel combustion) in United States in 1993 to that in 1998?
Provide a short and direct response. 1.17. What is the ratio of the CO2 emissions (% of total fuel combustion) of Libya in 1994 to that in 1995?
Ensure brevity in your answer.  0.98. What is the ratio of the CO2 emissions (% of total fuel combustion) of Mexico in 1994 to that in 1995?
Your answer should be compact. 0.96. What is the ratio of the CO2 emissions (% of total fuel combustion) of Paraguay in 1994 to that in 1995?
Keep it short and to the point. 1.07. What is the ratio of the CO2 emissions (% of total fuel combustion) of United States in 1994 to that in 1995?
Ensure brevity in your answer.  1. What is the ratio of the CO2 emissions (% of total fuel combustion) in Libya in 1994 to that in 1996?
Ensure brevity in your answer.  0.97. What is the ratio of the CO2 emissions (% of total fuel combustion) of Mexico in 1994 to that in 1996?
Provide a short and direct response. 1.01. What is the ratio of the CO2 emissions (% of total fuel combustion) in Paraguay in 1994 to that in 1996?
Your response must be concise. 1.01. What is the ratio of the CO2 emissions (% of total fuel combustion) in United States in 1994 to that in 1996?
Make the answer very short. 0.97. What is the ratio of the CO2 emissions (% of total fuel combustion) of Libya in 1994 to that in 1997?
Offer a terse response. 0.93. What is the ratio of the CO2 emissions (% of total fuel combustion) in Mexico in 1994 to that in 1997?
Make the answer very short. 1.05. What is the ratio of the CO2 emissions (% of total fuel combustion) in United States in 1994 to that in 1997?
Provide a succinct answer. 1.03. What is the ratio of the CO2 emissions (% of total fuel combustion) in Mexico in 1994 to that in 1998?
Your answer should be compact. 1.07. What is the ratio of the CO2 emissions (% of total fuel combustion) of Paraguay in 1994 to that in 1998?
Offer a terse response. 1.01. What is the ratio of the CO2 emissions (% of total fuel combustion) of United States in 1994 to that in 1998?
Your response must be concise. 1.13. What is the ratio of the CO2 emissions (% of total fuel combustion) of Libya in 1995 to that in 1996?
Give a very brief answer. 0.98. What is the ratio of the CO2 emissions (% of total fuel combustion) of Mexico in 1995 to that in 1996?
Offer a terse response. 1.05. What is the ratio of the CO2 emissions (% of total fuel combustion) of Paraguay in 1995 to that in 1996?
Offer a very short reply. 0.94. What is the ratio of the CO2 emissions (% of total fuel combustion) of United States in 1995 to that in 1996?
Ensure brevity in your answer.  0.97. What is the ratio of the CO2 emissions (% of total fuel combustion) of Libya in 1995 to that in 1997?
Your answer should be very brief. 0.95. What is the ratio of the CO2 emissions (% of total fuel combustion) in Mexico in 1995 to that in 1997?
Give a very brief answer. 1.1. What is the ratio of the CO2 emissions (% of total fuel combustion) in Paraguay in 1995 to that in 1997?
Provide a short and direct response. 0.99. What is the ratio of the CO2 emissions (% of total fuel combustion) of United States in 1995 to that in 1997?
Your answer should be compact. 1.03. What is the ratio of the CO2 emissions (% of total fuel combustion) in Libya in 1995 to that in 1998?
Make the answer very short. 0.95. What is the ratio of the CO2 emissions (% of total fuel combustion) in Mexico in 1995 to that in 1998?
Keep it short and to the point. 1.12. What is the ratio of the CO2 emissions (% of total fuel combustion) in Paraguay in 1995 to that in 1998?
Give a very brief answer. 0.94. What is the ratio of the CO2 emissions (% of total fuel combustion) of United States in 1995 to that in 1998?
Give a very brief answer. 1.13. What is the ratio of the CO2 emissions (% of total fuel combustion) in Libya in 1996 to that in 1997?
Ensure brevity in your answer.  0.96. What is the ratio of the CO2 emissions (% of total fuel combustion) of Mexico in 1996 to that in 1997?
Offer a terse response. 1.05. What is the ratio of the CO2 emissions (% of total fuel combustion) of Paraguay in 1996 to that in 1997?
Make the answer very short. 1.06. What is the ratio of the CO2 emissions (% of total fuel combustion) in United States in 1996 to that in 1997?
Make the answer very short. 1.06. What is the ratio of the CO2 emissions (% of total fuel combustion) of Libya in 1996 to that in 1998?
Offer a very short reply. 0.97. What is the ratio of the CO2 emissions (% of total fuel combustion) of Mexico in 1996 to that in 1998?
Keep it short and to the point. 1.06. What is the ratio of the CO2 emissions (% of total fuel combustion) in Paraguay in 1996 to that in 1998?
Your answer should be very brief. 1.01. What is the ratio of the CO2 emissions (% of total fuel combustion) in United States in 1996 to that in 1998?
Provide a short and direct response. 1.16. What is the ratio of the CO2 emissions (% of total fuel combustion) in Mexico in 1997 to that in 1998?
Give a very brief answer. 1.02. What is the ratio of the CO2 emissions (% of total fuel combustion) in Paraguay in 1997 to that in 1998?
Provide a short and direct response. 0.95. What is the ratio of the CO2 emissions (% of total fuel combustion) in United States in 1997 to that in 1998?
Your answer should be very brief. 1.09. What is the difference between the highest and the second highest CO2 emissions (% of total fuel combustion) in Libya?
Your answer should be compact. 0.04. What is the difference between the highest and the second highest CO2 emissions (% of total fuel combustion) of Mexico?
Offer a very short reply. 0.22. What is the difference between the highest and the second highest CO2 emissions (% of total fuel combustion) in Paraguay?
Provide a succinct answer. 0.46. What is the difference between the highest and the second highest CO2 emissions (% of total fuel combustion) of United States?
Offer a very short reply. 0.07. What is the difference between the highest and the lowest CO2 emissions (% of total fuel combustion) of Libya?
Make the answer very short. 0.41. What is the difference between the highest and the lowest CO2 emissions (% of total fuel combustion) in Mexico?
Offer a very short reply. 0.91. What is the difference between the highest and the lowest CO2 emissions (% of total fuel combustion) of Paraguay?
Keep it short and to the point. 1.05. What is the difference between the highest and the lowest CO2 emissions (% of total fuel combustion) of United States?
Provide a succinct answer. 1.67. 